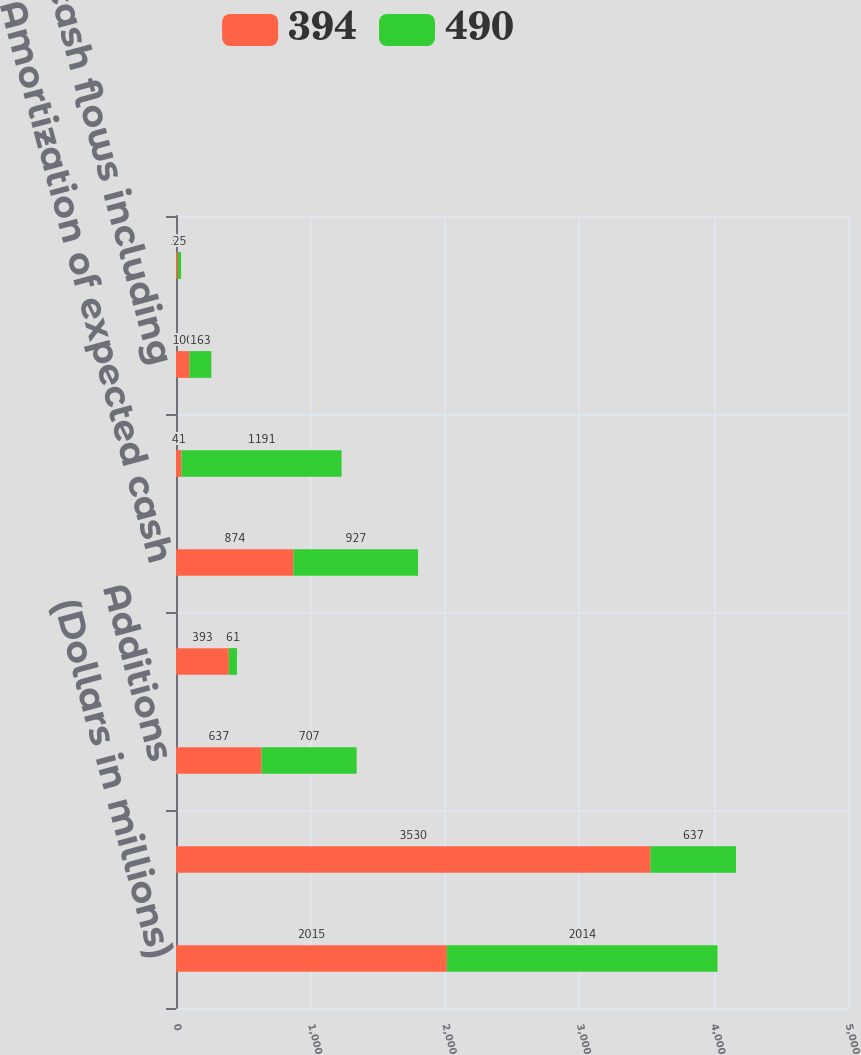Convert chart. <chart><loc_0><loc_0><loc_500><loc_500><stacked_bar_chart><ecel><fcel>(Dollars in millions)<fcel>Balance January 1<fcel>Additions<fcel>Sales<fcel>Amortization of expected cash<fcel>Impact of changes in interest<fcel>Projected cash flows including<fcel>Impact of changes in the Home<nl><fcel>394<fcel>2015<fcel>3530<fcel>637<fcel>393<fcel>874<fcel>41<fcel>100<fcel>13<nl><fcel>490<fcel>2014<fcel>637<fcel>707<fcel>61<fcel>927<fcel>1191<fcel>163<fcel>25<nl></chart> 